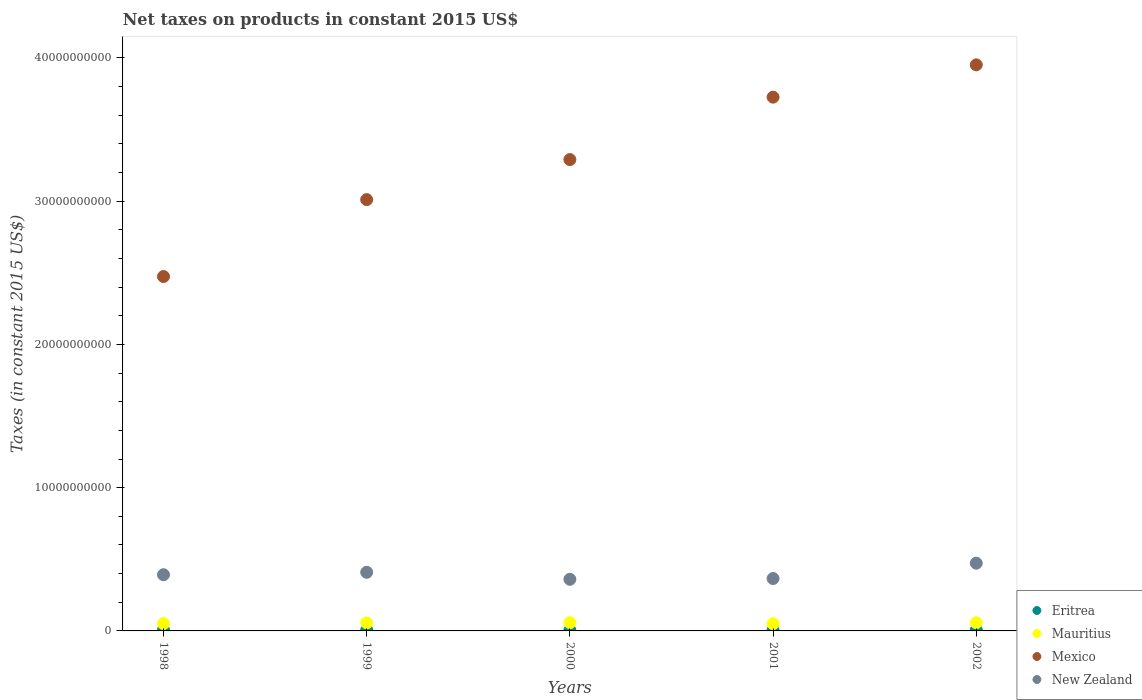Is the number of dotlines equal to the number of legend labels?
Provide a short and direct response. Yes. What is the net taxes on products in Eritrea in 1998?
Offer a terse response. 6.31e+07. Across all years, what is the maximum net taxes on products in Eritrea?
Make the answer very short. 7.06e+07. Across all years, what is the minimum net taxes on products in Mauritius?
Your answer should be compact. 5.02e+08. In which year was the net taxes on products in Mexico maximum?
Provide a short and direct response. 2002. In which year was the net taxes on products in Mauritius minimum?
Provide a succinct answer. 2001. What is the total net taxes on products in Mauritius in the graph?
Keep it short and to the point. 2.72e+09. What is the difference between the net taxes on products in Mexico in 1999 and that in 2001?
Your answer should be compact. -7.15e+09. What is the difference between the net taxes on products in New Zealand in 1999 and the net taxes on products in Mauritius in 2000?
Offer a very short reply. 3.52e+09. What is the average net taxes on products in Eritrea per year?
Provide a short and direct response. 5.76e+07. In the year 1999, what is the difference between the net taxes on products in Mexico and net taxes on products in Eritrea?
Provide a short and direct response. 3.00e+1. What is the ratio of the net taxes on products in Mexico in 1998 to that in 2000?
Provide a short and direct response. 0.75. Is the net taxes on products in Mexico in 1998 less than that in 2000?
Offer a terse response. Yes. What is the difference between the highest and the second highest net taxes on products in New Zealand?
Make the answer very short. 6.36e+08. What is the difference between the highest and the lowest net taxes on products in Mauritius?
Your response must be concise. 7.30e+07. Is the sum of the net taxes on products in Mexico in 2000 and 2001 greater than the maximum net taxes on products in Eritrea across all years?
Your answer should be compact. Yes. Is it the case that in every year, the sum of the net taxes on products in Mauritius and net taxes on products in Mexico  is greater than the net taxes on products in New Zealand?
Make the answer very short. Yes. Is the net taxes on products in Mexico strictly less than the net taxes on products in Eritrea over the years?
Offer a terse response. No. Does the graph contain grids?
Keep it short and to the point. No. How many legend labels are there?
Make the answer very short. 4. What is the title of the graph?
Keep it short and to the point. Net taxes on products in constant 2015 US$. What is the label or title of the Y-axis?
Your response must be concise. Taxes (in constant 2015 US$). What is the Taxes (in constant 2015 US$) of Eritrea in 1998?
Your response must be concise. 6.31e+07. What is the Taxes (in constant 2015 US$) in Mauritius in 1998?
Your answer should be very brief. 5.09e+08. What is the Taxes (in constant 2015 US$) in Mexico in 1998?
Ensure brevity in your answer.  2.47e+1. What is the Taxes (in constant 2015 US$) of New Zealand in 1998?
Give a very brief answer. 3.92e+09. What is the Taxes (in constant 2015 US$) of Eritrea in 1999?
Your answer should be very brief. 5.98e+07. What is the Taxes (in constant 2015 US$) of Mauritius in 1999?
Your response must be concise. 5.61e+08. What is the Taxes (in constant 2015 US$) in Mexico in 1999?
Provide a succinct answer. 3.01e+1. What is the Taxes (in constant 2015 US$) of New Zealand in 1999?
Ensure brevity in your answer.  4.09e+09. What is the Taxes (in constant 2015 US$) of Eritrea in 2000?
Provide a short and direct response. 4.44e+07. What is the Taxes (in constant 2015 US$) of Mauritius in 2000?
Keep it short and to the point. 5.75e+08. What is the Taxes (in constant 2015 US$) in Mexico in 2000?
Make the answer very short. 3.29e+1. What is the Taxes (in constant 2015 US$) of New Zealand in 2000?
Provide a succinct answer. 3.60e+09. What is the Taxes (in constant 2015 US$) in Eritrea in 2001?
Your answer should be compact. 5.02e+07. What is the Taxes (in constant 2015 US$) of Mauritius in 2001?
Your answer should be very brief. 5.02e+08. What is the Taxes (in constant 2015 US$) of Mexico in 2001?
Give a very brief answer. 3.73e+1. What is the Taxes (in constant 2015 US$) of New Zealand in 2001?
Provide a succinct answer. 3.66e+09. What is the Taxes (in constant 2015 US$) of Eritrea in 2002?
Provide a succinct answer. 7.06e+07. What is the Taxes (in constant 2015 US$) of Mauritius in 2002?
Provide a succinct answer. 5.69e+08. What is the Taxes (in constant 2015 US$) of Mexico in 2002?
Provide a short and direct response. 3.95e+1. What is the Taxes (in constant 2015 US$) of New Zealand in 2002?
Provide a short and direct response. 4.73e+09. Across all years, what is the maximum Taxes (in constant 2015 US$) in Eritrea?
Give a very brief answer. 7.06e+07. Across all years, what is the maximum Taxes (in constant 2015 US$) in Mauritius?
Your answer should be very brief. 5.75e+08. Across all years, what is the maximum Taxes (in constant 2015 US$) in Mexico?
Your answer should be very brief. 3.95e+1. Across all years, what is the maximum Taxes (in constant 2015 US$) of New Zealand?
Provide a short and direct response. 4.73e+09. Across all years, what is the minimum Taxes (in constant 2015 US$) of Eritrea?
Your response must be concise. 4.44e+07. Across all years, what is the minimum Taxes (in constant 2015 US$) in Mauritius?
Your response must be concise. 5.02e+08. Across all years, what is the minimum Taxes (in constant 2015 US$) of Mexico?
Offer a very short reply. 2.47e+1. Across all years, what is the minimum Taxes (in constant 2015 US$) of New Zealand?
Your answer should be very brief. 3.60e+09. What is the total Taxes (in constant 2015 US$) of Eritrea in the graph?
Make the answer very short. 2.88e+08. What is the total Taxes (in constant 2015 US$) in Mauritius in the graph?
Your answer should be compact. 2.72e+09. What is the total Taxes (in constant 2015 US$) in Mexico in the graph?
Your response must be concise. 1.65e+11. What is the total Taxes (in constant 2015 US$) in New Zealand in the graph?
Offer a terse response. 2.00e+1. What is the difference between the Taxes (in constant 2015 US$) in Eritrea in 1998 and that in 1999?
Offer a terse response. 3.34e+06. What is the difference between the Taxes (in constant 2015 US$) in Mauritius in 1998 and that in 1999?
Ensure brevity in your answer.  -5.25e+07. What is the difference between the Taxes (in constant 2015 US$) in Mexico in 1998 and that in 1999?
Offer a very short reply. -5.37e+09. What is the difference between the Taxes (in constant 2015 US$) of New Zealand in 1998 and that in 1999?
Give a very brief answer. -1.69e+08. What is the difference between the Taxes (in constant 2015 US$) of Eritrea in 1998 and that in 2000?
Your response must be concise. 1.87e+07. What is the difference between the Taxes (in constant 2015 US$) in Mauritius in 1998 and that in 2000?
Your answer should be compact. -6.59e+07. What is the difference between the Taxes (in constant 2015 US$) of Mexico in 1998 and that in 2000?
Ensure brevity in your answer.  -8.16e+09. What is the difference between the Taxes (in constant 2015 US$) of New Zealand in 1998 and that in 2000?
Make the answer very short. 3.20e+08. What is the difference between the Taxes (in constant 2015 US$) in Eritrea in 1998 and that in 2001?
Offer a very short reply. 1.29e+07. What is the difference between the Taxes (in constant 2015 US$) of Mauritius in 1998 and that in 2001?
Ensure brevity in your answer.  7.05e+06. What is the difference between the Taxes (in constant 2015 US$) of Mexico in 1998 and that in 2001?
Your answer should be very brief. -1.25e+1. What is the difference between the Taxes (in constant 2015 US$) in New Zealand in 1998 and that in 2001?
Ensure brevity in your answer.  2.65e+08. What is the difference between the Taxes (in constant 2015 US$) in Eritrea in 1998 and that in 2002?
Offer a terse response. -7.46e+06. What is the difference between the Taxes (in constant 2015 US$) in Mauritius in 1998 and that in 2002?
Provide a succinct answer. -6.06e+07. What is the difference between the Taxes (in constant 2015 US$) of Mexico in 1998 and that in 2002?
Ensure brevity in your answer.  -1.48e+1. What is the difference between the Taxes (in constant 2015 US$) of New Zealand in 1998 and that in 2002?
Make the answer very short. -8.05e+08. What is the difference between the Taxes (in constant 2015 US$) of Eritrea in 1999 and that in 2000?
Your answer should be very brief. 1.54e+07. What is the difference between the Taxes (in constant 2015 US$) in Mauritius in 1999 and that in 2000?
Make the answer very short. -1.34e+07. What is the difference between the Taxes (in constant 2015 US$) of Mexico in 1999 and that in 2000?
Give a very brief answer. -2.80e+09. What is the difference between the Taxes (in constant 2015 US$) of New Zealand in 1999 and that in 2000?
Offer a terse response. 4.89e+08. What is the difference between the Taxes (in constant 2015 US$) in Eritrea in 1999 and that in 2001?
Your response must be concise. 9.56e+06. What is the difference between the Taxes (in constant 2015 US$) in Mauritius in 1999 and that in 2001?
Your answer should be very brief. 5.95e+07. What is the difference between the Taxes (in constant 2015 US$) in Mexico in 1999 and that in 2001?
Offer a very short reply. -7.15e+09. What is the difference between the Taxes (in constant 2015 US$) in New Zealand in 1999 and that in 2001?
Offer a terse response. 4.34e+08. What is the difference between the Taxes (in constant 2015 US$) of Eritrea in 1999 and that in 2002?
Offer a very short reply. -1.08e+07. What is the difference between the Taxes (in constant 2015 US$) of Mauritius in 1999 and that in 2002?
Your answer should be compact. -8.13e+06. What is the difference between the Taxes (in constant 2015 US$) in Mexico in 1999 and that in 2002?
Offer a terse response. -9.41e+09. What is the difference between the Taxes (in constant 2015 US$) of New Zealand in 1999 and that in 2002?
Your answer should be compact. -6.36e+08. What is the difference between the Taxes (in constant 2015 US$) in Eritrea in 2000 and that in 2001?
Provide a succinct answer. -5.80e+06. What is the difference between the Taxes (in constant 2015 US$) of Mauritius in 2000 and that in 2001?
Your response must be concise. 7.30e+07. What is the difference between the Taxes (in constant 2015 US$) of Mexico in 2000 and that in 2001?
Offer a very short reply. -4.36e+09. What is the difference between the Taxes (in constant 2015 US$) of New Zealand in 2000 and that in 2001?
Your answer should be very brief. -5.55e+07. What is the difference between the Taxes (in constant 2015 US$) of Eritrea in 2000 and that in 2002?
Provide a short and direct response. -2.62e+07. What is the difference between the Taxes (in constant 2015 US$) in Mauritius in 2000 and that in 2002?
Keep it short and to the point. 5.29e+06. What is the difference between the Taxes (in constant 2015 US$) of Mexico in 2000 and that in 2002?
Your answer should be very brief. -6.61e+09. What is the difference between the Taxes (in constant 2015 US$) of New Zealand in 2000 and that in 2002?
Your answer should be compact. -1.13e+09. What is the difference between the Taxes (in constant 2015 US$) in Eritrea in 2001 and that in 2002?
Your answer should be very brief. -2.04e+07. What is the difference between the Taxes (in constant 2015 US$) in Mauritius in 2001 and that in 2002?
Your response must be concise. -6.77e+07. What is the difference between the Taxes (in constant 2015 US$) in Mexico in 2001 and that in 2002?
Your answer should be very brief. -2.26e+09. What is the difference between the Taxes (in constant 2015 US$) in New Zealand in 2001 and that in 2002?
Offer a very short reply. -1.07e+09. What is the difference between the Taxes (in constant 2015 US$) in Eritrea in 1998 and the Taxes (in constant 2015 US$) in Mauritius in 1999?
Your response must be concise. -4.98e+08. What is the difference between the Taxes (in constant 2015 US$) of Eritrea in 1998 and the Taxes (in constant 2015 US$) of Mexico in 1999?
Offer a terse response. -3.00e+1. What is the difference between the Taxes (in constant 2015 US$) of Eritrea in 1998 and the Taxes (in constant 2015 US$) of New Zealand in 1999?
Your response must be concise. -4.03e+09. What is the difference between the Taxes (in constant 2015 US$) of Mauritius in 1998 and the Taxes (in constant 2015 US$) of Mexico in 1999?
Give a very brief answer. -2.96e+1. What is the difference between the Taxes (in constant 2015 US$) in Mauritius in 1998 and the Taxes (in constant 2015 US$) in New Zealand in 1999?
Keep it short and to the point. -3.58e+09. What is the difference between the Taxes (in constant 2015 US$) in Mexico in 1998 and the Taxes (in constant 2015 US$) in New Zealand in 1999?
Your answer should be compact. 2.06e+1. What is the difference between the Taxes (in constant 2015 US$) in Eritrea in 1998 and the Taxes (in constant 2015 US$) in Mauritius in 2000?
Offer a very short reply. -5.12e+08. What is the difference between the Taxes (in constant 2015 US$) in Eritrea in 1998 and the Taxes (in constant 2015 US$) in Mexico in 2000?
Offer a terse response. -3.28e+1. What is the difference between the Taxes (in constant 2015 US$) in Eritrea in 1998 and the Taxes (in constant 2015 US$) in New Zealand in 2000?
Your answer should be very brief. -3.54e+09. What is the difference between the Taxes (in constant 2015 US$) of Mauritius in 1998 and the Taxes (in constant 2015 US$) of Mexico in 2000?
Offer a terse response. -3.24e+1. What is the difference between the Taxes (in constant 2015 US$) in Mauritius in 1998 and the Taxes (in constant 2015 US$) in New Zealand in 2000?
Keep it short and to the point. -3.09e+09. What is the difference between the Taxes (in constant 2015 US$) in Mexico in 1998 and the Taxes (in constant 2015 US$) in New Zealand in 2000?
Make the answer very short. 2.11e+1. What is the difference between the Taxes (in constant 2015 US$) in Eritrea in 1998 and the Taxes (in constant 2015 US$) in Mauritius in 2001?
Offer a terse response. -4.39e+08. What is the difference between the Taxes (in constant 2015 US$) in Eritrea in 1998 and the Taxes (in constant 2015 US$) in Mexico in 2001?
Your answer should be very brief. -3.72e+1. What is the difference between the Taxes (in constant 2015 US$) of Eritrea in 1998 and the Taxes (in constant 2015 US$) of New Zealand in 2001?
Ensure brevity in your answer.  -3.59e+09. What is the difference between the Taxes (in constant 2015 US$) of Mauritius in 1998 and the Taxes (in constant 2015 US$) of Mexico in 2001?
Offer a terse response. -3.67e+1. What is the difference between the Taxes (in constant 2015 US$) of Mauritius in 1998 and the Taxes (in constant 2015 US$) of New Zealand in 2001?
Your response must be concise. -3.15e+09. What is the difference between the Taxes (in constant 2015 US$) of Mexico in 1998 and the Taxes (in constant 2015 US$) of New Zealand in 2001?
Your answer should be compact. 2.11e+1. What is the difference between the Taxes (in constant 2015 US$) of Eritrea in 1998 and the Taxes (in constant 2015 US$) of Mauritius in 2002?
Ensure brevity in your answer.  -5.06e+08. What is the difference between the Taxes (in constant 2015 US$) of Eritrea in 1998 and the Taxes (in constant 2015 US$) of Mexico in 2002?
Make the answer very short. -3.94e+1. What is the difference between the Taxes (in constant 2015 US$) in Eritrea in 1998 and the Taxes (in constant 2015 US$) in New Zealand in 2002?
Your answer should be compact. -4.66e+09. What is the difference between the Taxes (in constant 2015 US$) in Mauritius in 1998 and the Taxes (in constant 2015 US$) in Mexico in 2002?
Give a very brief answer. -3.90e+1. What is the difference between the Taxes (in constant 2015 US$) of Mauritius in 1998 and the Taxes (in constant 2015 US$) of New Zealand in 2002?
Keep it short and to the point. -4.22e+09. What is the difference between the Taxes (in constant 2015 US$) of Mexico in 1998 and the Taxes (in constant 2015 US$) of New Zealand in 2002?
Provide a succinct answer. 2.00e+1. What is the difference between the Taxes (in constant 2015 US$) of Eritrea in 1999 and the Taxes (in constant 2015 US$) of Mauritius in 2000?
Your response must be concise. -5.15e+08. What is the difference between the Taxes (in constant 2015 US$) in Eritrea in 1999 and the Taxes (in constant 2015 US$) in Mexico in 2000?
Offer a terse response. -3.28e+1. What is the difference between the Taxes (in constant 2015 US$) in Eritrea in 1999 and the Taxes (in constant 2015 US$) in New Zealand in 2000?
Give a very brief answer. -3.54e+09. What is the difference between the Taxes (in constant 2015 US$) of Mauritius in 1999 and the Taxes (in constant 2015 US$) of Mexico in 2000?
Make the answer very short. -3.23e+1. What is the difference between the Taxes (in constant 2015 US$) of Mauritius in 1999 and the Taxes (in constant 2015 US$) of New Zealand in 2000?
Offer a very short reply. -3.04e+09. What is the difference between the Taxes (in constant 2015 US$) of Mexico in 1999 and the Taxes (in constant 2015 US$) of New Zealand in 2000?
Provide a short and direct response. 2.65e+1. What is the difference between the Taxes (in constant 2015 US$) in Eritrea in 1999 and the Taxes (in constant 2015 US$) in Mauritius in 2001?
Your answer should be compact. -4.42e+08. What is the difference between the Taxes (in constant 2015 US$) of Eritrea in 1999 and the Taxes (in constant 2015 US$) of Mexico in 2001?
Offer a very short reply. -3.72e+1. What is the difference between the Taxes (in constant 2015 US$) in Eritrea in 1999 and the Taxes (in constant 2015 US$) in New Zealand in 2001?
Your answer should be very brief. -3.60e+09. What is the difference between the Taxes (in constant 2015 US$) in Mauritius in 1999 and the Taxes (in constant 2015 US$) in Mexico in 2001?
Ensure brevity in your answer.  -3.67e+1. What is the difference between the Taxes (in constant 2015 US$) of Mauritius in 1999 and the Taxes (in constant 2015 US$) of New Zealand in 2001?
Keep it short and to the point. -3.10e+09. What is the difference between the Taxes (in constant 2015 US$) of Mexico in 1999 and the Taxes (in constant 2015 US$) of New Zealand in 2001?
Give a very brief answer. 2.64e+1. What is the difference between the Taxes (in constant 2015 US$) of Eritrea in 1999 and the Taxes (in constant 2015 US$) of Mauritius in 2002?
Your answer should be compact. -5.10e+08. What is the difference between the Taxes (in constant 2015 US$) in Eritrea in 1999 and the Taxes (in constant 2015 US$) in Mexico in 2002?
Offer a very short reply. -3.95e+1. What is the difference between the Taxes (in constant 2015 US$) of Eritrea in 1999 and the Taxes (in constant 2015 US$) of New Zealand in 2002?
Offer a terse response. -4.67e+09. What is the difference between the Taxes (in constant 2015 US$) in Mauritius in 1999 and the Taxes (in constant 2015 US$) in Mexico in 2002?
Provide a short and direct response. -3.90e+1. What is the difference between the Taxes (in constant 2015 US$) in Mauritius in 1999 and the Taxes (in constant 2015 US$) in New Zealand in 2002?
Your answer should be very brief. -4.17e+09. What is the difference between the Taxes (in constant 2015 US$) of Mexico in 1999 and the Taxes (in constant 2015 US$) of New Zealand in 2002?
Make the answer very short. 2.54e+1. What is the difference between the Taxes (in constant 2015 US$) in Eritrea in 2000 and the Taxes (in constant 2015 US$) in Mauritius in 2001?
Make the answer very short. -4.57e+08. What is the difference between the Taxes (in constant 2015 US$) in Eritrea in 2000 and the Taxes (in constant 2015 US$) in Mexico in 2001?
Your answer should be very brief. -3.72e+1. What is the difference between the Taxes (in constant 2015 US$) of Eritrea in 2000 and the Taxes (in constant 2015 US$) of New Zealand in 2001?
Provide a succinct answer. -3.61e+09. What is the difference between the Taxes (in constant 2015 US$) of Mauritius in 2000 and the Taxes (in constant 2015 US$) of Mexico in 2001?
Provide a succinct answer. -3.67e+1. What is the difference between the Taxes (in constant 2015 US$) of Mauritius in 2000 and the Taxes (in constant 2015 US$) of New Zealand in 2001?
Provide a succinct answer. -3.08e+09. What is the difference between the Taxes (in constant 2015 US$) of Mexico in 2000 and the Taxes (in constant 2015 US$) of New Zealand in 2001?
Your answer should be compact. 2.92e+1. What is the difference between the Taxes (in constant 2015 US$) in Eritrea in 2000 and the Taxes (in constant 2015 US$) in Mauritius in 2002?
Ensure brevity in your answer.  -5.25e+08. What is the difference between the Taxes (in constant 2015 US$) in Eritrea in 2000 and the Taxes (in constant 2015 US$) in Mexico in 2002?
Make the answer very short. -3.95e+1. What is the difference between the Taxes (in constant 2015 US$) of Eritrea in 2000 and the Taxes (in constant 2015 US$) of New Zealand in 2002?
Give a very brief answer. -4.68e+09. What is the difference between the Taxes (in constant 2015 US$) of Mauritius in 2000 and the Taxes (in constant 2015 US$) of Mexico in 2002?
Keep it short and to the point. -3.89e+1. What is the difference between the Taxes (in constant 2015 US$) in Mauritius in 2000 and the Taxes (in constant 2015 US$) in New Zealand in 2002?
Your answer should be very brief. -4.15e+09. What is the difference between the Taxes (in constant 2015 US$) in Mexico in 2000 and the Taxes (in constant 2015 US$) in New Zealand in 2002?
Your answer should be compact. 2.82e+1. What is the difference between the Taxes (in constant 2015 US$) in Eritrea in 2001 and the Taxes (in constant 2015 US$) in Mauritius in 2002?
Your response must be concise. -5.19e+08. What is the difference between the Taxes (in constant 2015 US$) in Eritrea in 2001 and the Taxes (in constant 2015 US$) in Mexico in 2002?
Give a very brief answer. -3.95e+1. What is the difference between the Taxes (in constant 2015 US$) in Eritrea in 2001 and the Taxes (in constant 2015 US$) in New Zealand in 2002?
Provide a short and direct response. -4.68e+09. What is the difference between the Taxes (in constant 2015 US$) in Mauritius in 2001 and the Taxes (in constant 2015 US$) in Mexico in 2002?
Your answer should be very brief. -3.90e+1. What is the difference between the Taxes (in constant 2015 US$) in Mauritius in 2001 and the Taxes (in constant 2015 US$) in New Zealand in 2002?
Your response must be concise. -4.23e+09. What is the difference between the Taxes (in constant 2015 US$) of Mexico in 2001 and the Taxes (in constant 2015 US$) of New Zealand in 2002?
Offer a very short reply. 3.25e+1. What is the average Taxes (in constant 2015 US$) in Eritrea per year?
Give a very brief answer. 5.76e+07. What is the average Taxes (in constant 2015 US$) in Mauritius per year?
Provide a succinct answer. 5.43e+08. What is the average Taxes (in constant 2015 US$) in Mexico per year?
Keep it short and to the point. 3.29e+1. What is the average Taxes (in constant 2015 US$) in New Zealand per year?
Give a very brief answer. 4.00e+09. In the year 1998, what is the difference between the Taxes (in constant 2015 US$) in Eritrea and Taxes (in constant 2015 US$) in Mauritius?
Provide a short and direct response. -4.46e+08. In the year 1998, what is the difference between the Taxes (in constant 2015 US$) of Eritrea and Taxes (in constant 2015 US$) of Mexico?
Your answer should be very brief. -2.47e+1. In the year 1998, what is the difference between the Taxes (in constant 2015 US$) in Eritrea and Taxes (in constant 2015 US$) in New Zealand?
Your answer should be very brief. -3.86e+09. In the year 1998, what is the difference between the Taxes (in constant 2015 US$) of Mauritius and Taxes (in constant 2015 US$) of Mexico?
Your answer should be very brief. -2.42e+1. In the year 1998, what is the difference between the Taxes (in constant 2015 US$) of Mauritius and Taxes (in constant 2015 US$) of New Zealand?
Offer a terse response. -3.41e+09. In the year 1998, what is the difference between the Taxes (in constant 2015 US$) of Mexico and Taxes (in constant 2015 US$) of New Zealand?
Offer a terse response. 2.08e+1. In the year 1999, what is the difference between the Taxes (in constant 2015 US$) in Eritrea and Taxes (in constant 2015 US$) in Mauritius?
Ensure brevity in your answer.  -5.01e+08. In the year 1999, what is the difference between the Taxes (in constant 2015 US$) of Eritrea and Taxes (in constant 2015 US$) of Mexico?
Ensure brevity in your answer.  -3.00e+1. In the year 1999, what is the difference between the Taxes (in constant 2015 US$) in Eritrea and Taxes (in constant 2015 US$) in New Zealand?
Your response must be concise. -4.03e+09. In the year 1999, what is the difference between the Taxes (in constant 2015 US$) of Mauritius and Taxes (in constant 2015 US$) of Mexico?
Your answer should be very brief. -2.95e+1. In the year 1999, what is the difference between the Taxes (in constant 2015 US$) in Mauritius and Taxes (in constant 2015 US$) in New Zealand?
Offer a very short reply. -3.53e+09. In the year 1999, what is the difference between the Taxes (in constant 2015 US$) in Mexico and Taxes (in constant 2015 US$) in New Zealand?
Offer a terse response. 2.60e+1. In the year 2000, what is the difference between the Taxes (in constant 2015 US$) in Eritrea and Taxes (in constant 2015 US$) in Mauritius?
Your answer should be very brief. -5.30e+08. In the year 2000, what is the difference between the Taxes (in constant 2015 US$) in Eritrea and Taxes (in constant 2015 US$) in Mexico?
Your answer should be very brief. -3.29e+1. In the year 2000, what is the difference between the Taxes (in constant 2015 US$) in Eritrea and Taxes (in constant 2015 US$) in New Zealand?
Make the answer very short. -3.56e+09. In the year 2000, what is the difference between the Taxes (in constant 2015 US$) in Mauritius and Taxes (in constant 2015 US$) in Mexico?
Your answer should be compact. -3.23e+1. In the year 2000, what is the difference between the Taxes (in constant 2015 US$) of Mauritius and Taxes (in constant 2015 US$) of New Zealand?
Offer a very short reply. -3.03e+09. In the year 2000, what is the difference between the Taxes (in constant 2015 US$) of Mexico and Taxes (in constant 2015 US$) of New Zealand?
Your answer should be compact. 2.93e+1. In the year 2001, what is the difference between the Taxes (in constant 2015 US$) of Eritrea and Taxes (in constant 2015 US$) of Mauritius?
Provide a short and direct response. -4.51e+08. In the year 2001, what is the difference between the Taxes (in constant 2015 US$) in Eritrea and Taxes (in constant 2015 US$) in Mexico?
Your answer should be very brief. -3.72e+1. In the year 2001, what is the difference between the Taxes (in constant 2015 US$) of Eritrea and Taxes (in constant 2015 US$) of New Zealand?
Ensure brevity in your answer.  -3.61e+09. In the year 2001, what is the difference between the Taxes (in constant 2015 US$) in Mauritius and Taxes (in constant 2015 US$) in Mexico?
Your response must be concise. -3.68e+1. In the year 2001, what is the difference between the Taxes (in constant 2015 US$) of Mauritius and Taxes (in constant 2015 US$) of New Zealand?
Your answer should be very brief. -3.16e+09. In the year 2001, what is the difference between the Taxes (in constant 2015 US$) in Mexico and Taxes (in constant 2015 US$) in New Zealand?
Offer a terse response. 3.36e+1. In the year 2002, what is the difference between the Taxes (in constant 2015 US$) of Eritrea and Taxes (in constant 2015 US$) of Mauritius?
Provide a short and direct response. -4.99e+08. In the year 2002, what is the difference between the Taxes (in constant 2015 US$) of Eritrea and Taxes (in constant 2015 US$) of Mexico?
Give a very brief answer. -3.94e+1. In the year 2002, what is the difference between the Taxes (in constant 2015 US$) of Eritrea and Taxes (in constant 2015 US$) of New Zealand?
Provide a short and direct response. -4.66e+09. In the year 2002, what is the difference between the Taxes (in constant 2015 US$) of Mauritius and Taxes (in constant 2015 US$) of Mexico?
Your answer should be very brief. -3.89e+1. In the year 2002, what is the difference between the Taxes (in constant 2015 US$) in Mauritius and Taxes (in constant 2015 US$) in New Zealand?
Ensure brevity in your answer.  -4.16e+09. In the year 2002, what is the difference between the Taxes (in constant 2015 US$) of Mexico and Taxes (in constant 2015 US$) of New Zealand?
Give a very brief answer. 3.48e+1. What is the ratio of the Taxes (in constant 2015 US$) of Eritrea in 1998 to that in 1999?
Give a very brief answer. 1.06. What is the ratio of the Taxes (in constant 2015 US$) of Mauritius in 1998 to that in 1999?
Ensure brevity in your answer.  0.91. What is the ratio of the Taxes (in constant 2015 US$) of Mexico in 1998 to that in 1999?
Keep it short and to the point. 0.82. What is the ratio of the Taxes (in constant 2015 US$) of New Zealand in 1998 to that in 1999?
Give a very brief answer. 0.96. What is the ratio of the Taxes (in constant 2015 US$) in Eritrea in 1998 to that in 2000?
Offer a very short reply. 1.42. What is the ratio of the Taxes (in constant 2015 US$) in Mauritius in 1998 to that in 2000?
Provide a succinct answer. 0.89. What is the ratio of the Taxes (in constant 2015 US$) in Mexico in 1998 to that in 2000?
Your response must be concise. 0.75. What is the ratio of the Taxes (in constant 2015 US$) of New Zealand in 1998 to that in 2000?
Provide a succinct answer. 1.09. What is the ratio of the Taxes (in constant 2015 US$) of Eritrea in 1998 to that in 2001?
Offer a very short reply. 1.26. What is the ratio of the Taxes (in constant 2015 US$) in Mauritius in 1998 to that in 2001?
Your answer should be very brief. 1.01. What is the ratio of the Taxes (in constant 2015 US$) of Mexico in 1998 to that in 2001?
Keep it short and to the point. 0.66. What is the ratio of the Taxes (in constant 2015 US$) of New Zealand in 1998 to that in 2001?
Provide a succinct answer. 1.07. What is the ratio of the Taxes (in constant 2015 US$) of Eritrea in 1998 to that in 2002?
Make the answer very short. 0.89. What is the ratio of the Taxes (in constant 2015 US$) of Mauritius in 1998 to that in 2002?
Provide a short and direct response. 0.89. What is the ratio of the Taxes (in constant 2015 US$) in Mexico in 1998 to that in 2002?
Keep it short and to the point. 0.63. What is the ratio of the Taxes (in constant 2015 US$) in New Zealand in 1998 to that in 2002?
Keep it short and to the point. 0.83. What is the ratio of the Taxes (in constant 2015 US$) in Eritrea in 1999 to that in 2000?
Provide a short and direct response. 1.35. What is the ratio of the Taxes (in constant 2015 US$) in Mauritius in 1999 to that in 2000?
Provide a short and direct response. 0.98. What is the ratio of the Taxes (in constant 2015 US$) in Mexico in 1999 to that in 2000?
Your response must be concise. 0.92. What is the ratio of the Taxes (in constant 2015 US$) in New Zealand in 1999 to that in 2000?
Your answer should be compact. 1.14. What is the ratio of the Taxes (in constant 2015 US$) of Eritrea in 1999 to that in 2001?
Keep it short and to the point. 1.19. What is the ratio of the Taxes (in constant 2015 US$) of Mauritius in 1999 to that in 2001?
Provide a short and direct response. 1.12. What is the ratio of the Taxes (in constant 2015 US$) of Mexico in 1999 to that in 2001?
Your answer should be compact. 0.81. What is the ratio of the Taxes (in constant 2015 US$) in New Zealand in 1999 to that in 2001?
Offer a very short reply. 1.12. What is the ratio of the Taxes (in constant 2015 US$) of Eritrea in 1999 to that in 2002?
Ensure brevity in your answer.  0.85. What is the ratio of the Taxes (in constant 2015 US$) in Mauritius in 1999 to that in 2002?
Provide a short and direct response. 0.99. What is the ratio of the Taxes (in constant 2015 US$) in Mexico in 1999 to that in 2002?
Offer a very short reply. 0.76. What is the ratio of the Taxes (in constant 2015 US$) in New Zealand in 1999 to that in 2002?
Provide a short and direct response. 0.87. What is the ratio of the Taxes (in constant 2015 US$) of Eritrea in 2000 to that in 2001?
Provide a short and direct response. 0.88. What is the ratio of the Taxes (in constant 2015 US$) in Mauritius in 2000 to that in 2001?
Ensure brevity in your answer.  1.15. What is the ratio of the Taxes (in constant 2015 US$) of Mexico in 2000 to that in 2001?
Ensure brevity in your answer.  0.88. What is the ratio of the Taxes (in constant 2015 US$) of Eritrea in 2000 to that in 2002?
Make the answer very short. 0.63. What is the ratio of the Taxes (in constant 2015 US$) of Mauritius in 2000 to that in 2002?
Your response must be concise. 1.01. What is the ratio of the Taxes (in constant 2015 US$) of Mexico in 2000 to that in 2002?
Your answer should be compact. 0.83. What is the ratio of the Taxes (in constant 2015 US$) in New Zealand in 2000 to that in 2002?
Offer a terse response. 0.76. What is the ratio of the Taxes (in constant 2015 US$) of Eritrea in 2001 to that in 2002?
Provide a short and direct response. 0.71. What is the ratio of the Taxes (in constant 2015 US$) of Mauritius in 2001 to that in 2002?
Give a very brief answer. 0.88. What is the ratio of the Taxes (in constant 2015 US$) of Mexico in 2001 to that in 2002?
Provide a succinct answer. 0.94. What is the ratio of the Taxes (in constant 2015 US$) in New Zealand in 2001 to that in 2002?
Your response must be concise. 0.77. What is the difference between the highest and the second highest Taxes (in constant 2015 US$) of Eritrea?
Your answer should be very brief. 7.46e+06. What is the difference between the highest and the second highest Taxes (in constant 2015 US$) in Mauritius?
Offer a very short reply. 5.29e+06. What is the difference between the highest and the second highest Taxes (in constant 2015 US$) of Mexico?
Make the answer very short. 2.26e+09. What is the difference between the highest and the second highest Taxes (in constant 2015 US$) of New Zealand?
Your answer should be compact. 6.36e+08. What is the difference between the highest and the lowest Taxes (in constant 2015 US$) in Eritrea?
Your response must be concise. 2.62e+07. What is the difference between the highest and the lowest Taxes (in constant 2015 US$) in Mauritius?
Make the answer very short. 7.30e+07. What is the difference between the highest and the lowest Taxes (in constant 2015 US$) in Mexico?
Your answer should be compact. 1.48e+1. What is the difference between the highest and the lowest Taxes (in constant 2015 US$) of New Zealand?
Ensure brevity in your answer.  1.13e+09. 